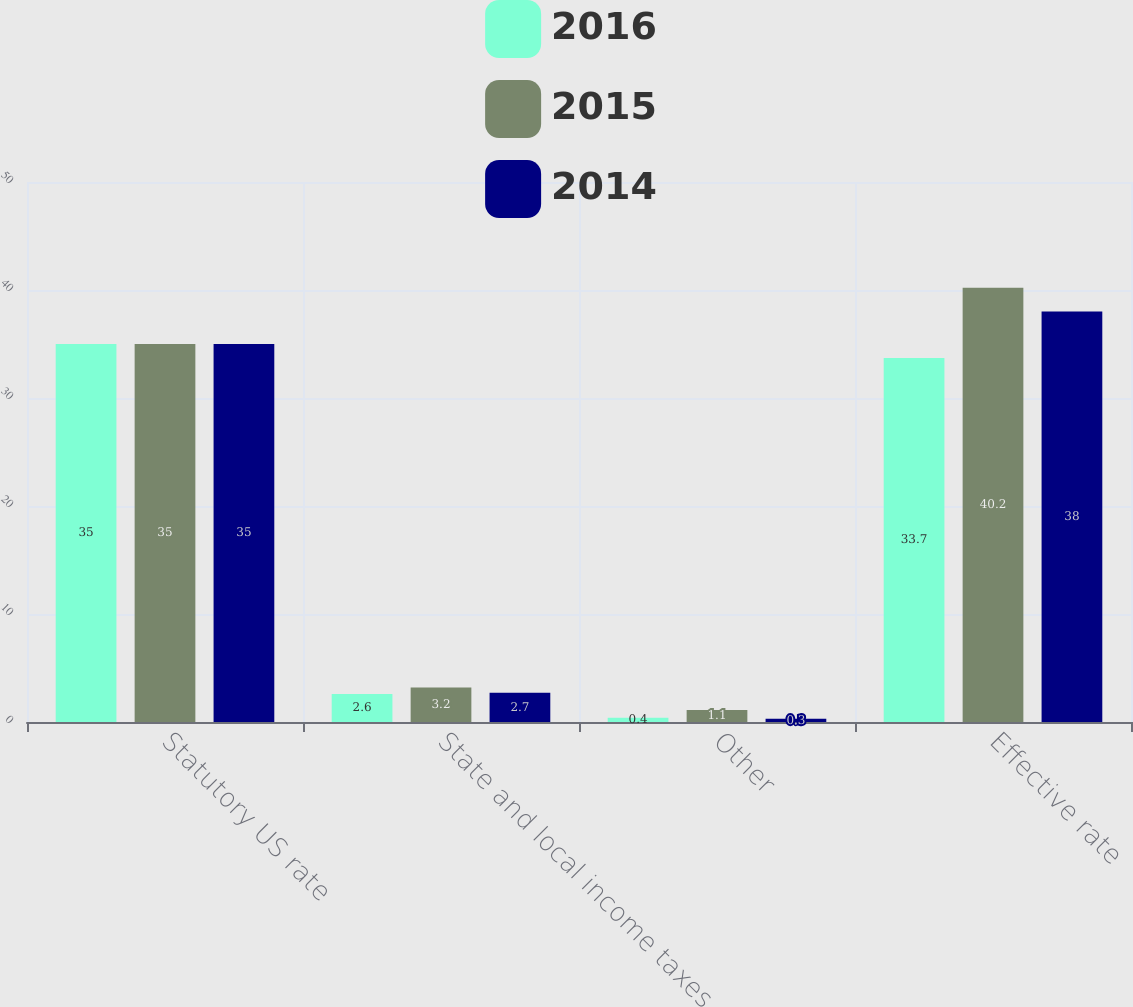<chart> <loc_0><loc_0><loc_500><loc_500><stacked_bar_chart><ecel><fcel>Statutory US rate<fcel>State and local income taxes<fcel>Other<fcel>Effective rate<nl><fcel>2016<fcel>35<fcel>2.6<fcel>0.4<fcel>33.7<nl><fcel>2015<fcel>35<fcel>3.2<fcel>1.1<fcel>40.2<nl><fcel>2014<fcel>35<fcel>2.7<fcel>0.3<fcel>38<nl></chart> 